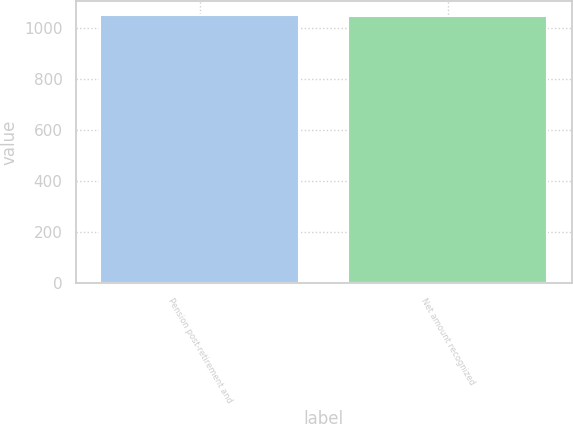<chart> <loc_0><loc_0><loc_500><loc_500><bar_chart><fcel>Pension post-retirement and<fcel>Net amount recognized<nl><fcel>1053<fcel>1049<nl></chart> 